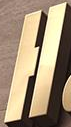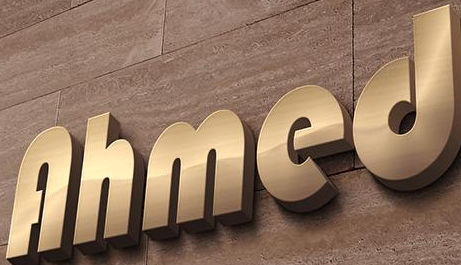Identify the words shown in these images in order, separated by a semicolon. H; Ahmed 